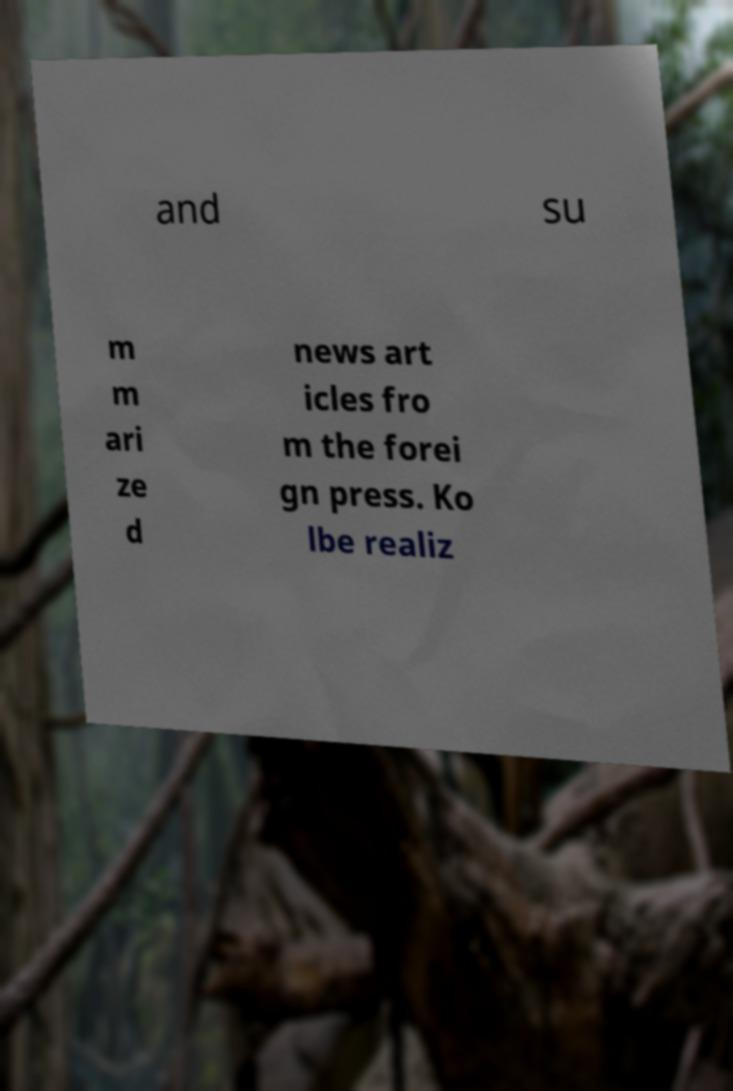For documentation purposes, I need the text within this image transcribed. Could you provide that? and su m m ari ze d news art icles fro m the forei gn press. Ko lbe realiz 